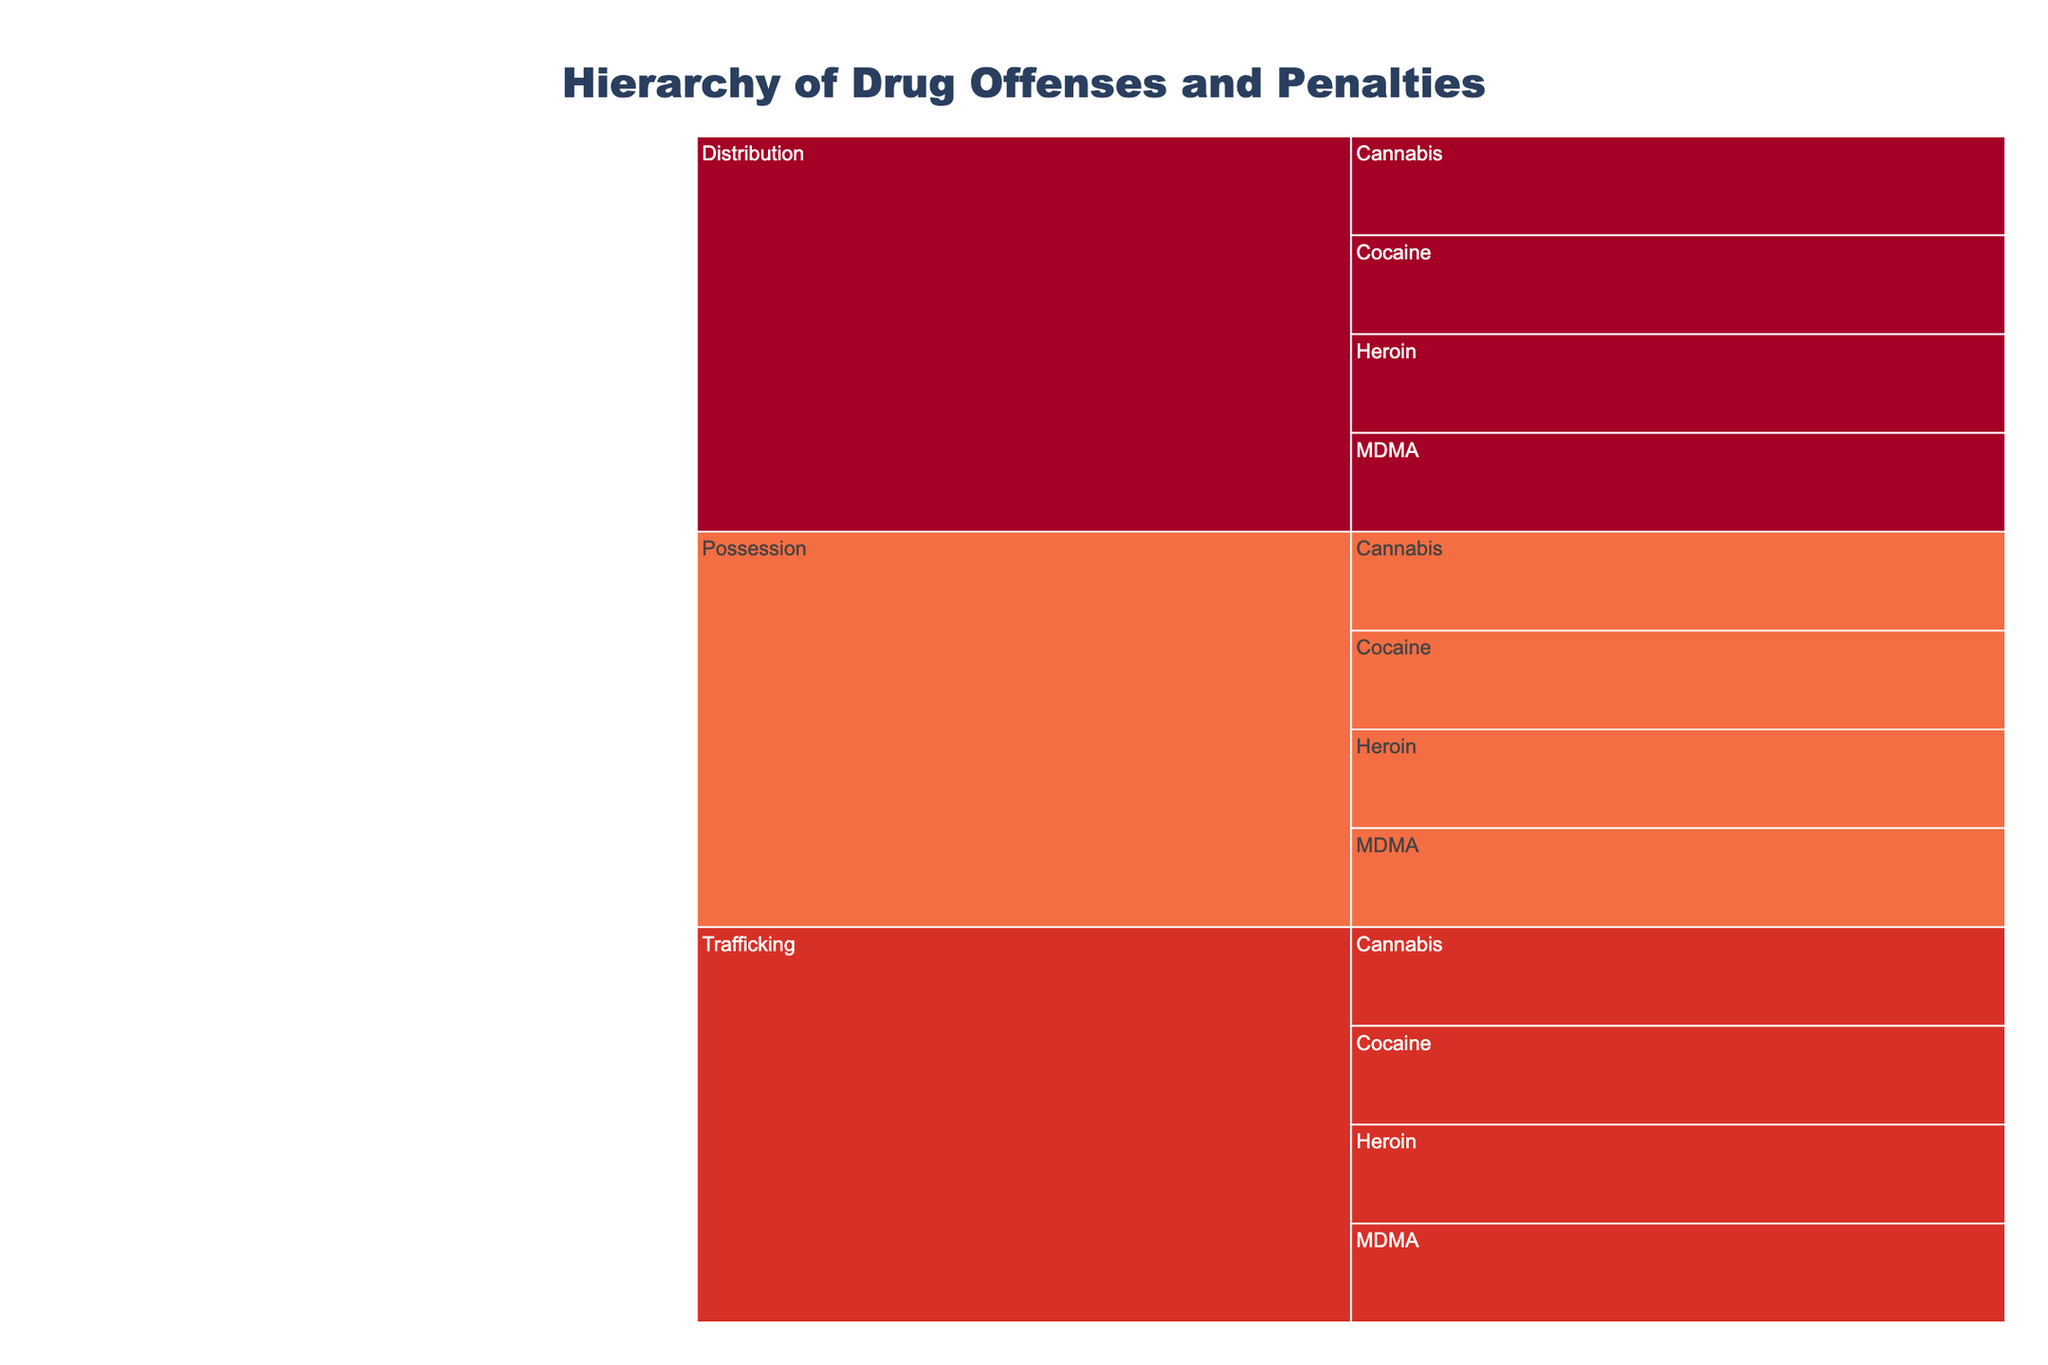What is the title of the chart? The title is shown at the top of the chart. It reads "Hierarchy of Drug Offenses and Penalties".
Answer: Hierarchy of Drug Offenses and Penalties How are the drug offenses organized in the chart? The offenses are organized hierarchically first by Category (Possession, Distribution, Trafficking) and then by Offense (Cannabis, Cocaine, etc.).
Answer: By Category and Offense What color is used for the 'Possession' category? By looking at the chart, each category is color-coded. The specific color for 'Possession' is visible in the chart.
Answer: Check the color representation in the chart How does the penalty for 'Possession of Cannabis' change after decriminalization? Locate the 'Possession' category and find 'Cannabis'. The penalties before and after decriminalization are displayed. Before: Misdemeanor (up to 1 year), After: Civil fine ($100).
Answer: Misdemeanor (up to 1 year) to Civil fine ($100) By how many years was the maximum penalty for 'Distribution of Heroin' reduced after decriminalization? Identify 'Distribution' and then 'Heroin'. The maximum penalty before decriminalization is 30 years and after is 10 years. The difference is 30 - 10 = 20 years.
Answer: 20 years For which offenses did the penalty become a 'Civil fine' after decriminalization? Scan through the chart to find offenses with penalties listed as 'Civil fine' after decriminalization. The offenses include 'Possession of Cannabis' and 'Possession of MDMA'.
Answer: Possession of Cannabis, Possession of MDMA Which offense has the highest maximum penalty after decriminalization? Check all maximum penalties listed after decriminalization in the chart and identify the highest one. 'Trafficking of Heroin' has the highest with 30 years.
Answer: Trafficking of Heroin (30 years) Was there any decrease in the penalty for 'Trafficking of Cocaine' after decriminalization? If so, by how many years? Locate 'Trafficking' and then 'Cocaine'. The maximum penalty before decriminalization is 30 years and after is 20 years. The difference is 30 - 20 = 10 years.
Answer: Yes, 10 years Which category generally has more severe penalties, 'Possession' or 'Distribution', both before and after decriminalization? Compare penalties for all offenses under 'Possession' and 'Distribution' categories before and after decriminalization. 'Distribution' generally has more severe penalties compared to 'Possession'.
Answer: Distribution 